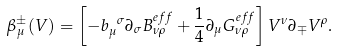<formula> <loc_0><loc_0><loc_500><loc_500>\beta ^ { \pm } _ { \mu } ( V ) = \left [ - b _ { \mu } ^ { \ \sigma } \partial _ { \sigma } B ^ { e f f } _ { \nu \rho } + \frac { 1 } { 4 } \partial _ { \mu } G ^ { e f f } _ { \nu \rho } \right ] V ^ { \nu } \partial _ { \mp } V ^ { \rho } .</formula> 